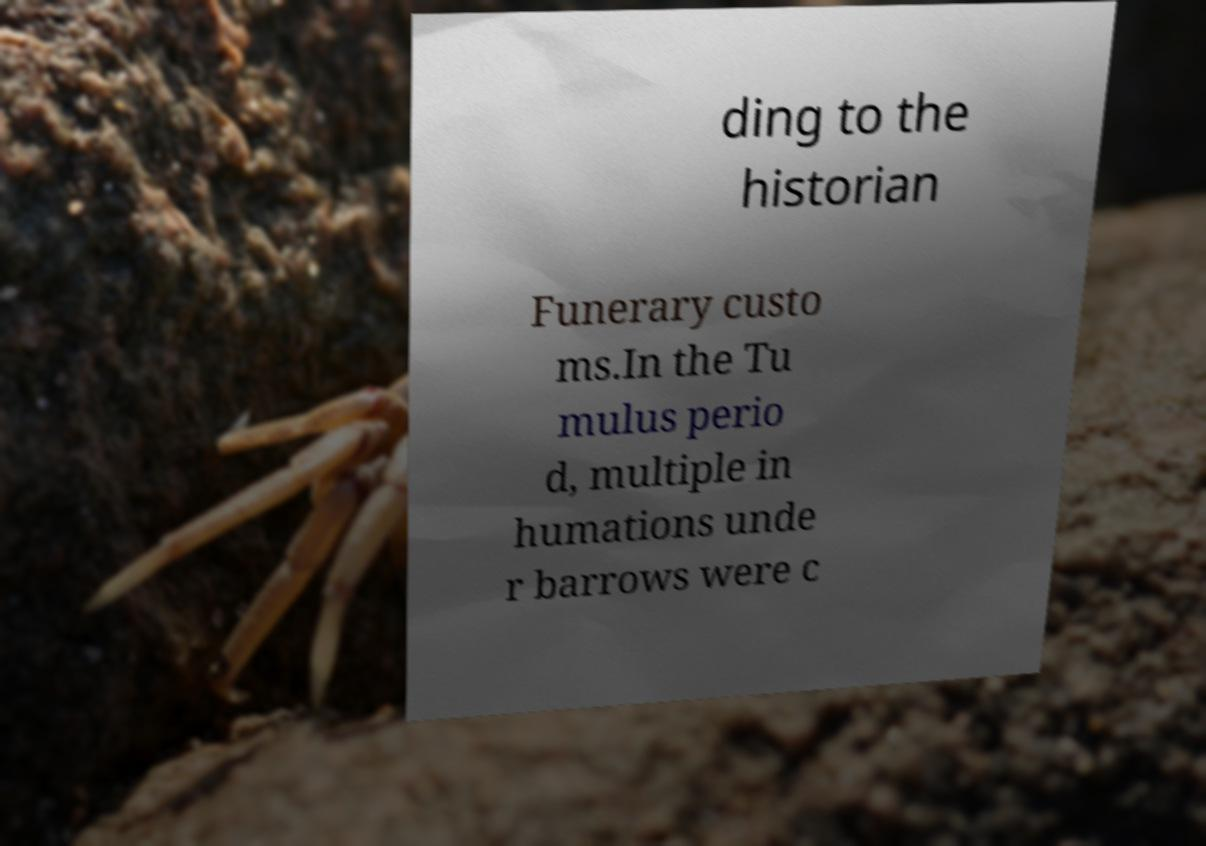Please read and relay the text visible in this image. What does it say? ding to the historian Funerary custo ms.In the Tu mulus perio d, multiple in humations unde r barrows were c 